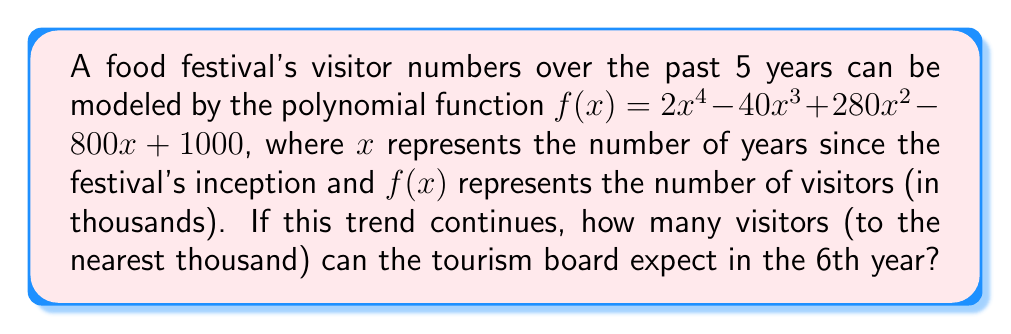Help me with this question. To solve this problem, we need to follow these steps:

1) We are given the polynomial function:
   $f(x) = 2x^4 - 40x^3 + 280x^2 - 800x + 1000$

2) We need to find $f(6)$ since we want to know the visitor numbers for the 6th year.

3) Let's substitute $x = 6$ into the function:

   $f(6) = 2(6)^4 - 40(6)^3 + 280(6)^2 - 800(6) + 1000$

4) Now, let's calculate each term:
   - $2(6)^4 = 2(1296) = 2592$
   - $-40(6)^3 = -40(216) = -8640$
   - $280(6)^2 = 280(36) = 10080$
   - $-800(6) = -4800$
   - $1000$ remains as is

5) Sum up all the terms:
   $f(6) = 2592 - 8640 + 10080 - 4800 + 1000 = 232$

6) Remember, the function gives the result in thousands. So, 232 thousand visitors are expected.

7) Rounding to the nearest thousand gives us 232,000 visitors.
Answer: 232,000 visitors 